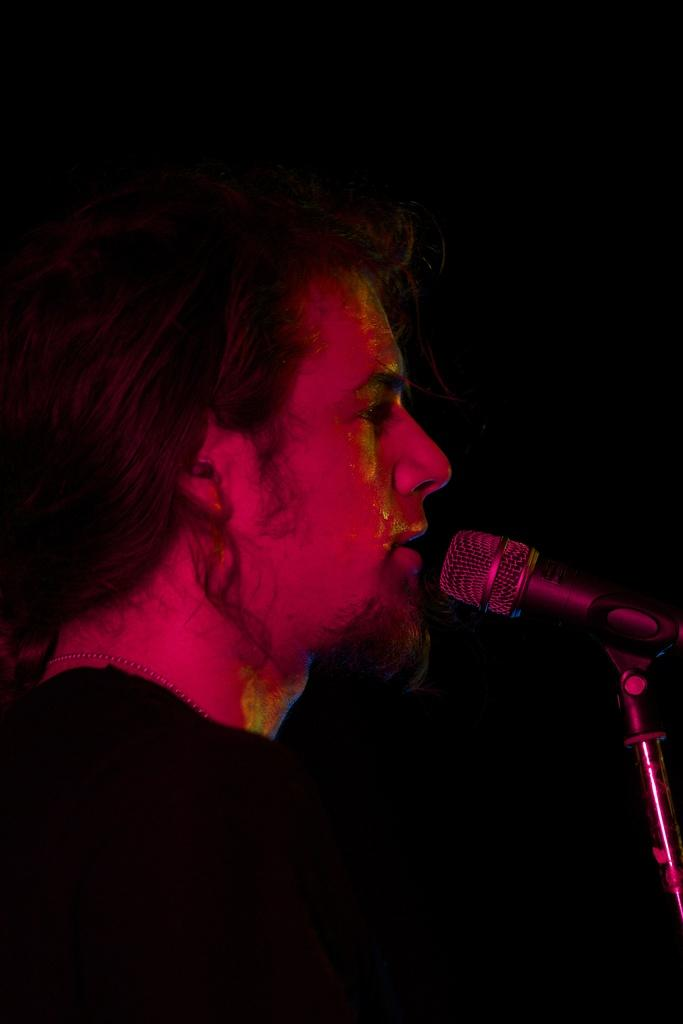Who is the main subject in the foreground of the image? There is a man in the foreground of the image. What object is present on the right side of the image? There is a microphone attached to a stand on the right side of the image. How would you describe the lighting in the background of the image? The background of the image is very dark. What type of chairs can be seen in the image? There are no chairs present in the image. What is the man's opinion on the topic being discussed in the image? The image does not provide any information about the man's opinion on a topic, as it only shows him standing with a microphone. 